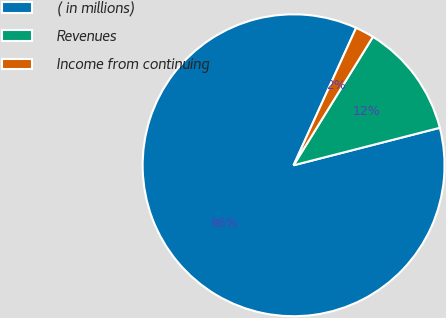Convert chart to OTSL. <chart><loc_0><loc_0><loc_500><loc_500><pie_chart><fcel>( in millions)<fcel>Revenues<fcel>Income from continuing<nl><fcel>85.79%<fcel>12.2%<fcel>2.01%<nl></chart> 